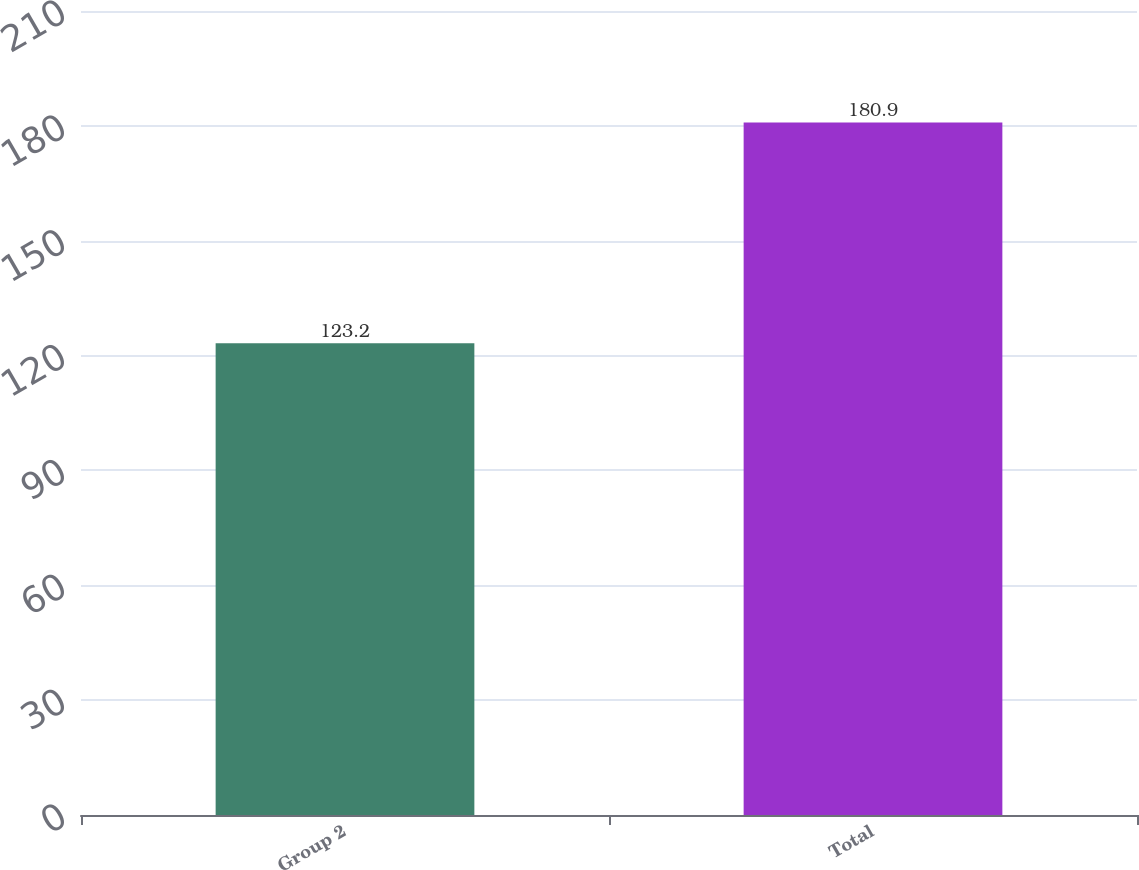<chart> <loc_0><loc_0><loc_500><loc_500><bar_chart><fcel>Group 2<fcel>Total<nl><fcel>123.2<fcel>180.9<nl></chart> 